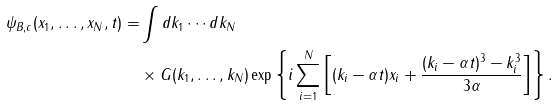<formula> <loc_0><loc_0><loc_500><loc_500>\psi _ { B , c } ( x _ { 1 } , \dots , x _ { N } , t ) = & \int d k _ { 1 } \cdots d k _ { N } \\ & \times G ( k _ { 1 } , \dots , k _ { N } ) \exp \left \{ i \sum _ { i = 1 } ^ { N } \left [ ( k _ { i } - \alpha t ) x _ { i } + \frac { ( k _ { i } - \alpha t ) ^ { 3 } - k _ { i } ^ { 3 } } { 3 \alpha } \right ] \right \} .</formula> 